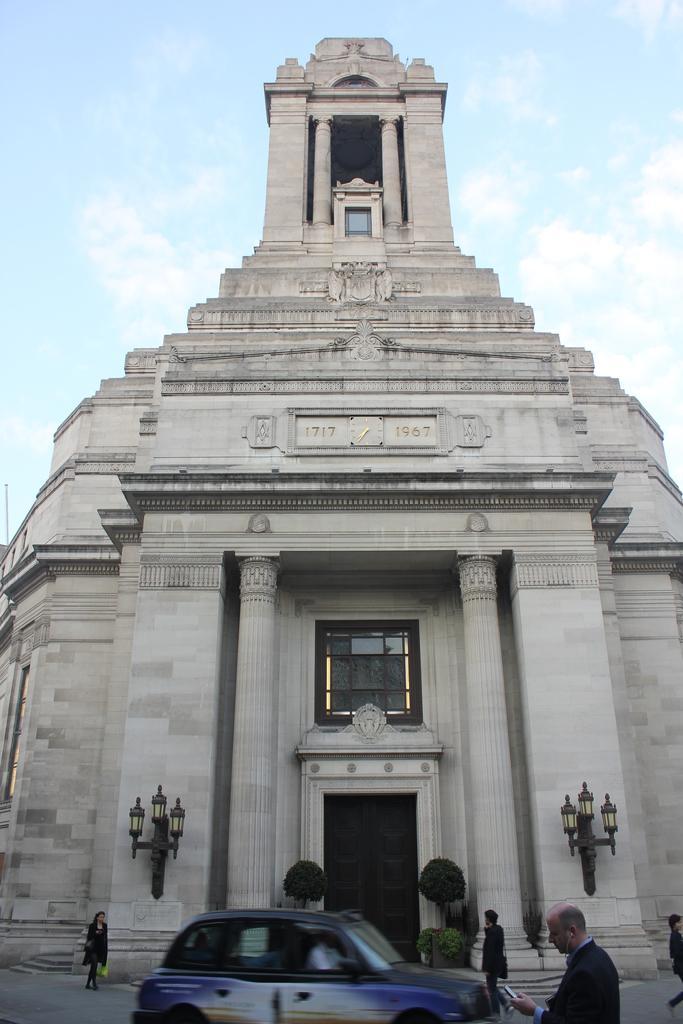Please provide a concise description of this image. In the image, there is a car moving from left to right side. On right side there is a man holding a mobile and a person walking. On left side there is a woman walking and holding a carry bag. In background there is a building,door,street light and sky is on top. 